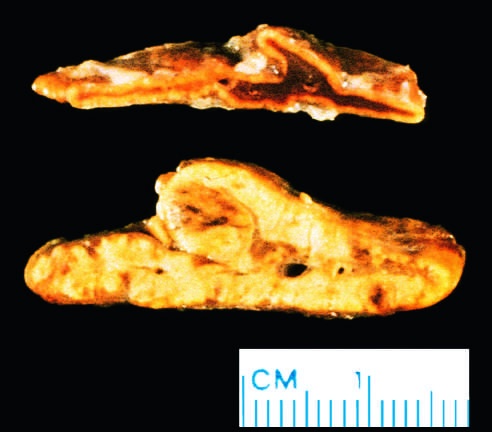s the adrenal cortex yellow and thickened?
Answer the question using a single word or phrase. Yes 